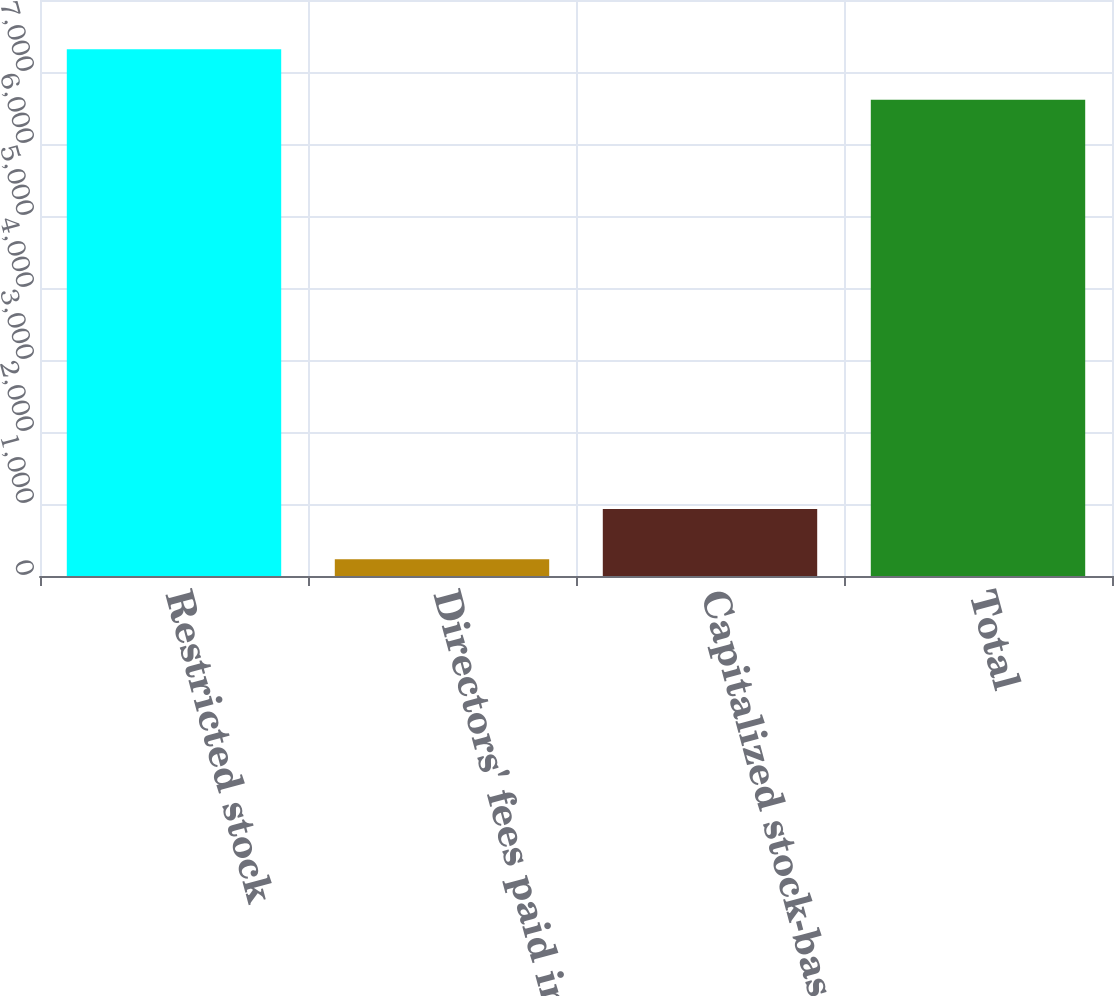Convert chart to OTSL. <chart><loc_0><loc_0><loc_500><loc_500><bar_chart><fcel>Restricted stock<fcel>Directors' fees paid in common<fcel>Capitalized stock-based<fcel>Total<nl><fcel>7315.5<fcel>231<fcel>931.5<fcel>6615<nl></chart> 